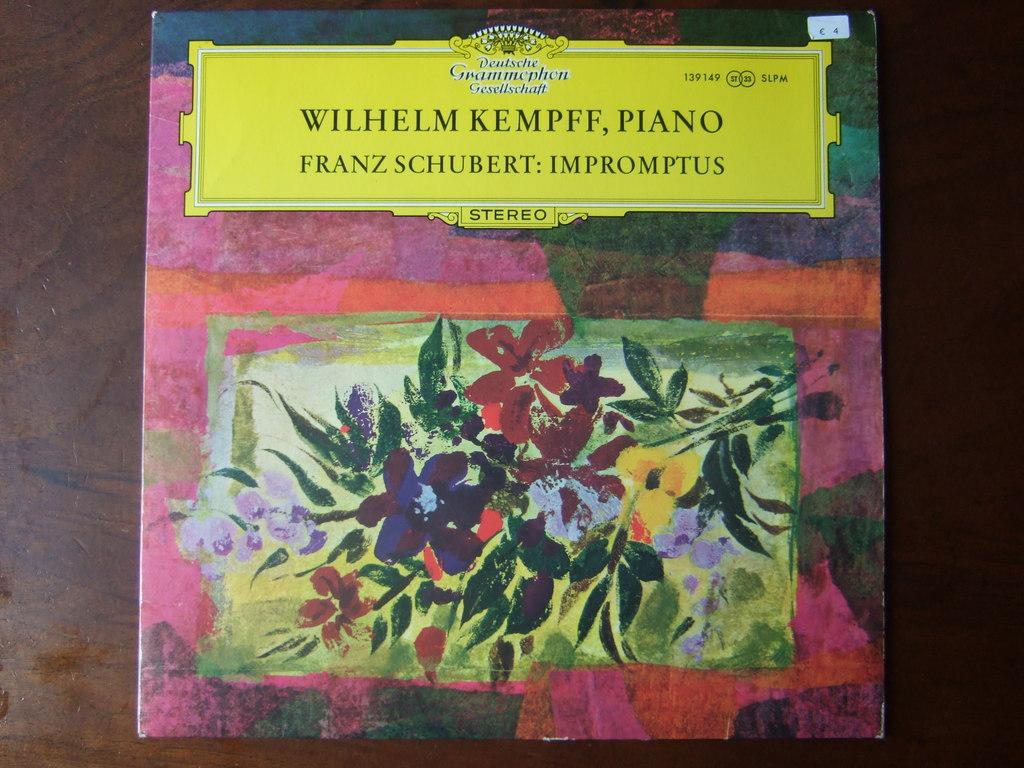Who wrote the book?
Ensure brevity in your answer.  Franz schubert. 